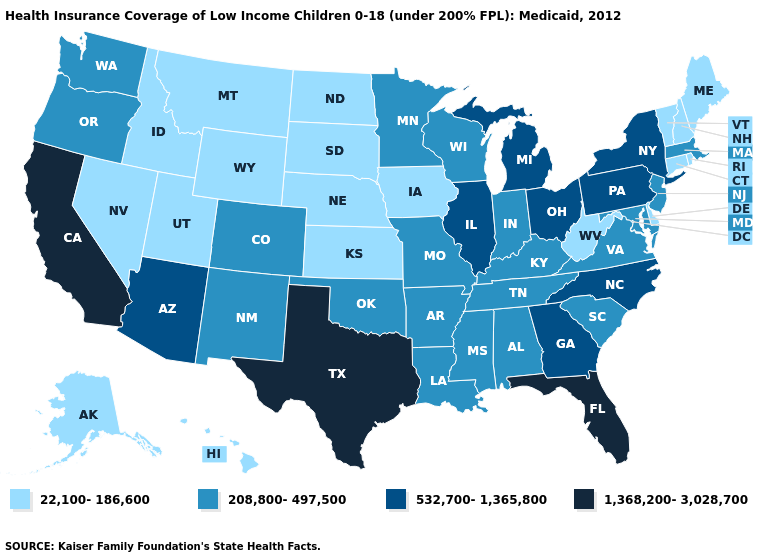Which states have the lowest value in the Northeast?
Short answer required. Connecticut, Maine, New Hampshire, Rhode Island, Vermont. What is the highest value in the Northeast ?
Quick response, please. 532,700-1,365,800. Which states have the lowest value in the West?
Short answer required. Alaska, Hawaii, Idaho, Montana, Nevada, Utah, Wyoming. What is the value of Arizona?
Write a very short answer. 532,700-1,365,800. Which states hav the highest value in the West?
Write a very short answer. California. What is the highest value in the South ?
Keep it brief. 1,368,200-3,028,700. Among the states that border Kentucky , which have the highest value?
Short answer required. Illinois, Ohio. Does California have the highest value in the USA?
Short answer required. Yes. Name the states that have a value in the range 532,700-1,365,800?
Keep it brief. Arizona, Georgia, Illinois, Michigan, New York, North Carolina, Ohio, Pennsylvania. Does Arkansas have a lower value than Minnesota?
Be succinct. No. Is the legend a continuous bar?
Write a very short answer. No. Name the states that have a value in the range 22,100-186,600?
Concise answer only. Alaska, Connecticut, Delaware, Hawaii, Idaho, Iowa, Kansas, Maine, Montana, Nebraska, Nevada, New Hampshire, North Dakota, Rhode Island, South Dakota, Utah, Vermont, West Virginia, Wyoming. What is the lowest value in the USA?
Concise answer only. 22,100-186,600. What is the highest value in states that border Alabama?
Short answer required. 1,368,200-3,028,700. Name the states that have a value in the range 22,100-186,600?
Be succinct. Alaska, Connecticut, Delaware, Hawaii, Idaho, Iowa, Kansas, Maine, Montana, Nebraska, Nevada, New Hampshire, North Dakota, Rhode Island, South Dakota, Utah, Vermont, West Virginia, Wyoming. 